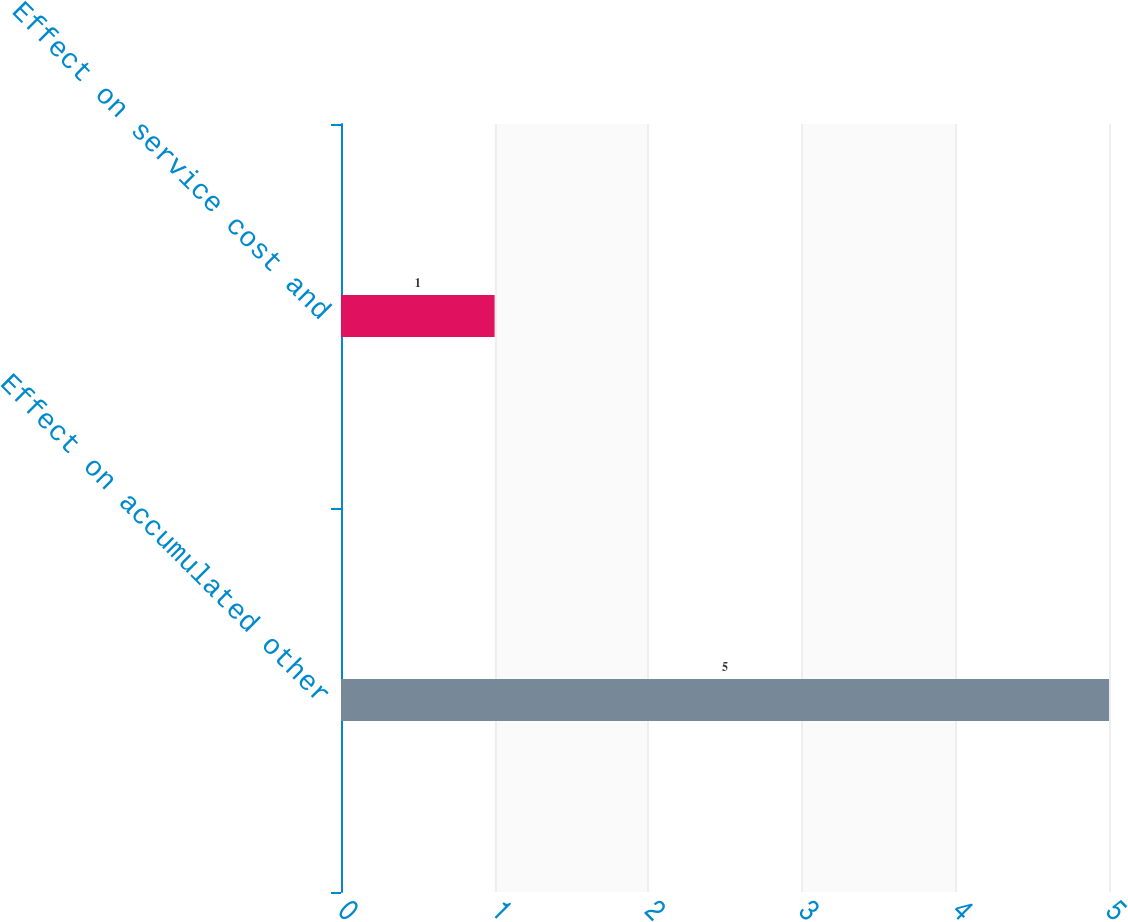<chart> <loc_0><loc_0><loc_500><loc_500><bar_chart><fcel>Effect on accumulated other<fcel>Effect on service cost and<nl><fcel>5<fcel>1<nl></chart> 